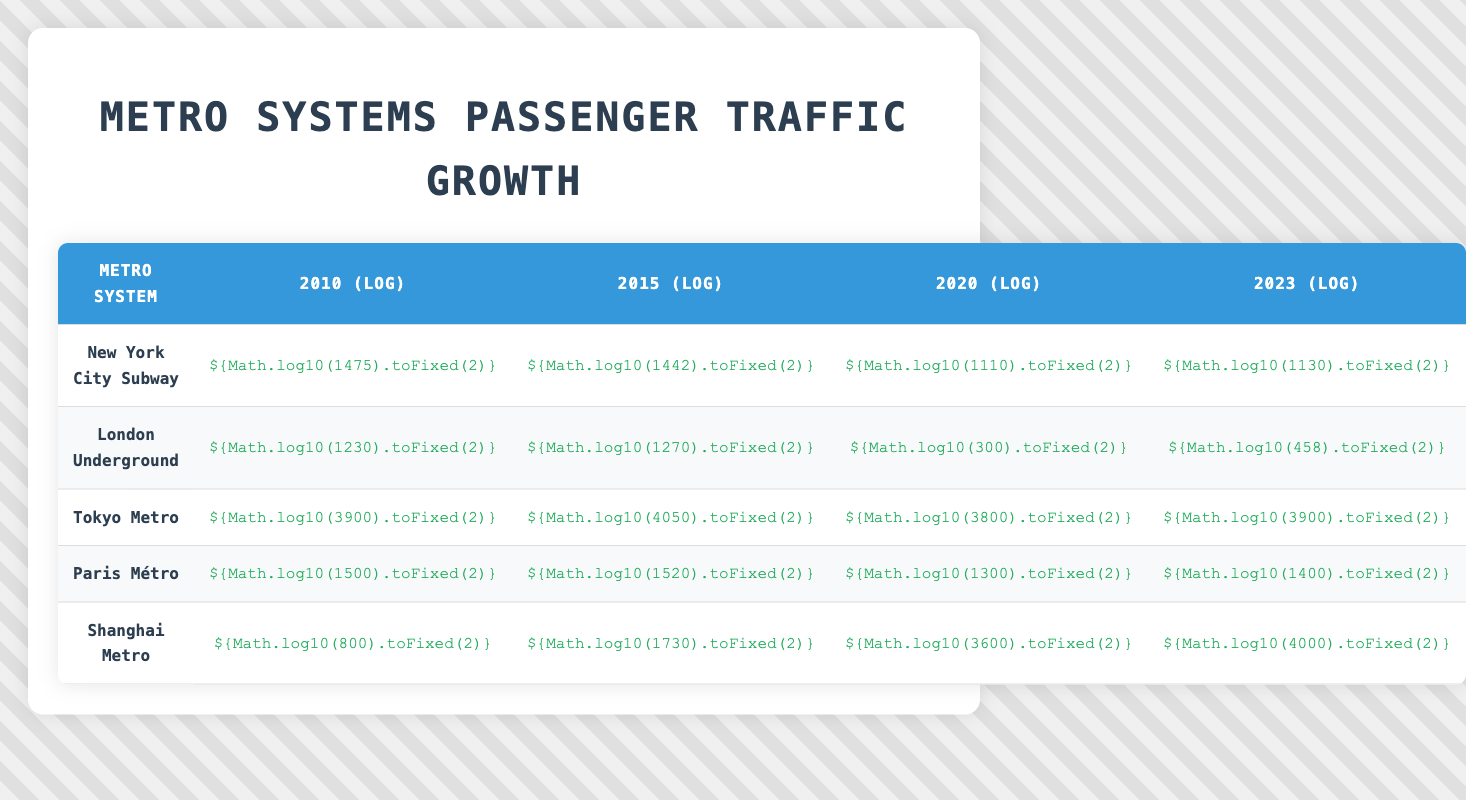what was the passenger traffic (log value) for the New York City Subway in 2015? According to the table, the log value for the New York City Subway in 2015 is clearly shown in the relevant column for that year.
Answer: 3.16 which metro system had the highest passenger traffic (log value) in 2020? By looking at the log values in the 2020 column, we see that Tokyo Metro has the highest value at 3.58, compared to the other systems listed.
Answer: Tokyo Metro what was the percentage increase in passenger traffic (log value) for the Shanghai Metro from 2010 to 2015? The log values for 2010 and 2015 are 2.90 and 3.19, respectively. To calculate the percentage increase: (3.19 - 2.90) / 2.90 * 100 = 10% increase.
Answer: 10% is the log value for passenger traffic of London Underground in 2020 lower than in 2015? The log value for London Underground in 2015 is 3.10 and in 2020 it is 2.48. Since 2.48 is lower than 3.10, the statement is true.
Answer: Yes what was the average passenger traffic (log value) across all metro systems for the year 2023? To find the average for 2023, sum the log values (for 2023) from each metro system: (3.04 + 2.66 + 3.59 + 3.15 + 3.60) = 15.04. The average is then 15.04 / 5 = 3.01.
Answer: 3.01 which metro system showed a consistent increase in log values from 2010 to 2023? Examining the log values from 2010 to 2023, the Shanghai Metro follows an increasing trend: 2.90, 3.19, 3.56, 3.60. Thus, it consistently increases.
Answer: Shanghai Metro what is the difference in log values between the highest and lowest passenger traffic for the Paris Métro from 2010 to 2023? The log value for Paris Métro in 2010 is 3.18 and in 2023 is 3.15. The difference is 3.18 - 3.15 = 0.03.
Answer: 0.03 how many metro systems had a log value above 3.0 in 2020? Checking the 2020 column, we can see that both Tokyo Metro (3.58) and Shanghai Metro (3.56) had log values above 3.0. Thus, there are 2 metro systems.
Answer: 2 